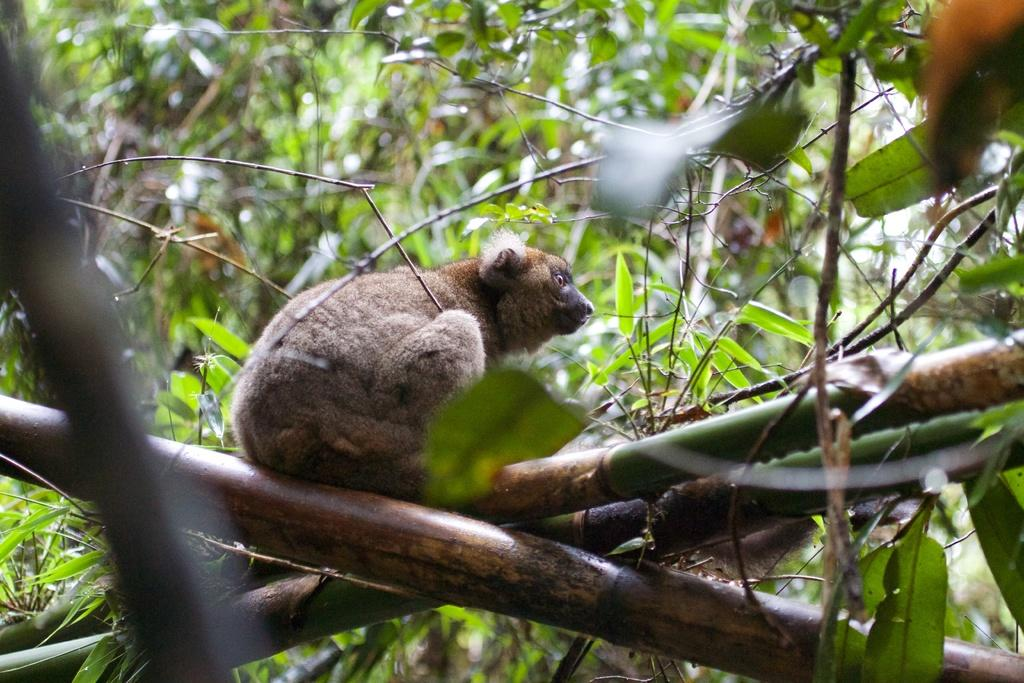What type of animal is in the image? There is an animal in the image, but the specific type cannot be determined from the provided facts. What else can be seen in the image besides the animal? There are sticks visible in the image. What can be seen in the background of the image? There are trees in the background of the image. Where is the basin located in the image? There is no basin present in the image. How does the animal blow out the candles in the image? There are no candles present in the image, and therefore the animal cannot blow them out. 